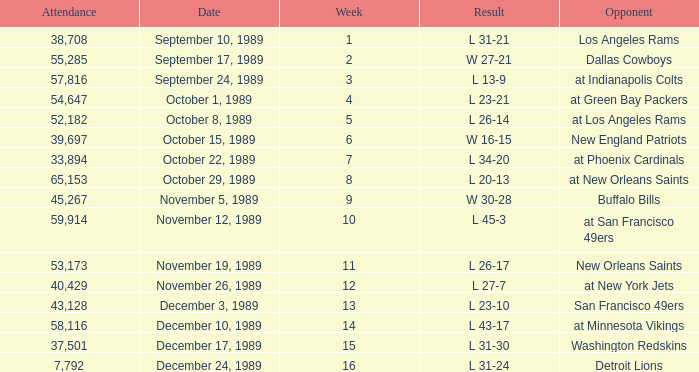For what week was the attendance 40,429? 12.0. 